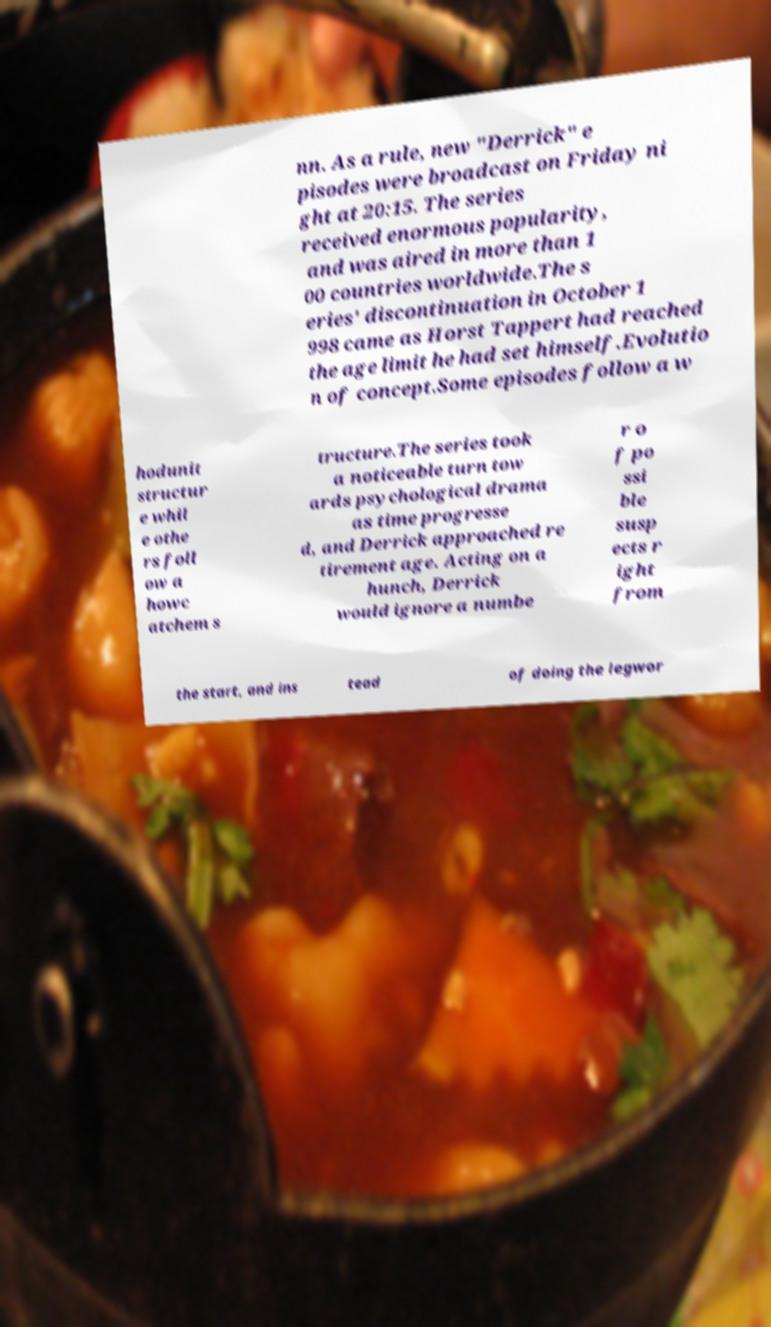Please read and relay the text visible in this image. What does it say? nn. As a rule, new "Derrick" e pisodes were broadcast on Friday ni ght at 20:15. The series received enormous popularity, and was aired in more than 1 00 countries worldwide.The s eries' discontinuation in October 1 998 came as Horst Tappert had reached the age limit he had set himself.Evolutio n of concept.Some episodes follow a w hodunit structur e whil e othe rs foll ow a howc atchem s tructure.The series took a noticeable turn tow ards psychological drama as time progresse d, and Derrick approached re tirement age. Acting on a hunch, Derrick would ignore a numbe r o f po ssi ble susp ects r ight from the start, and ins tead of doing the legwor 